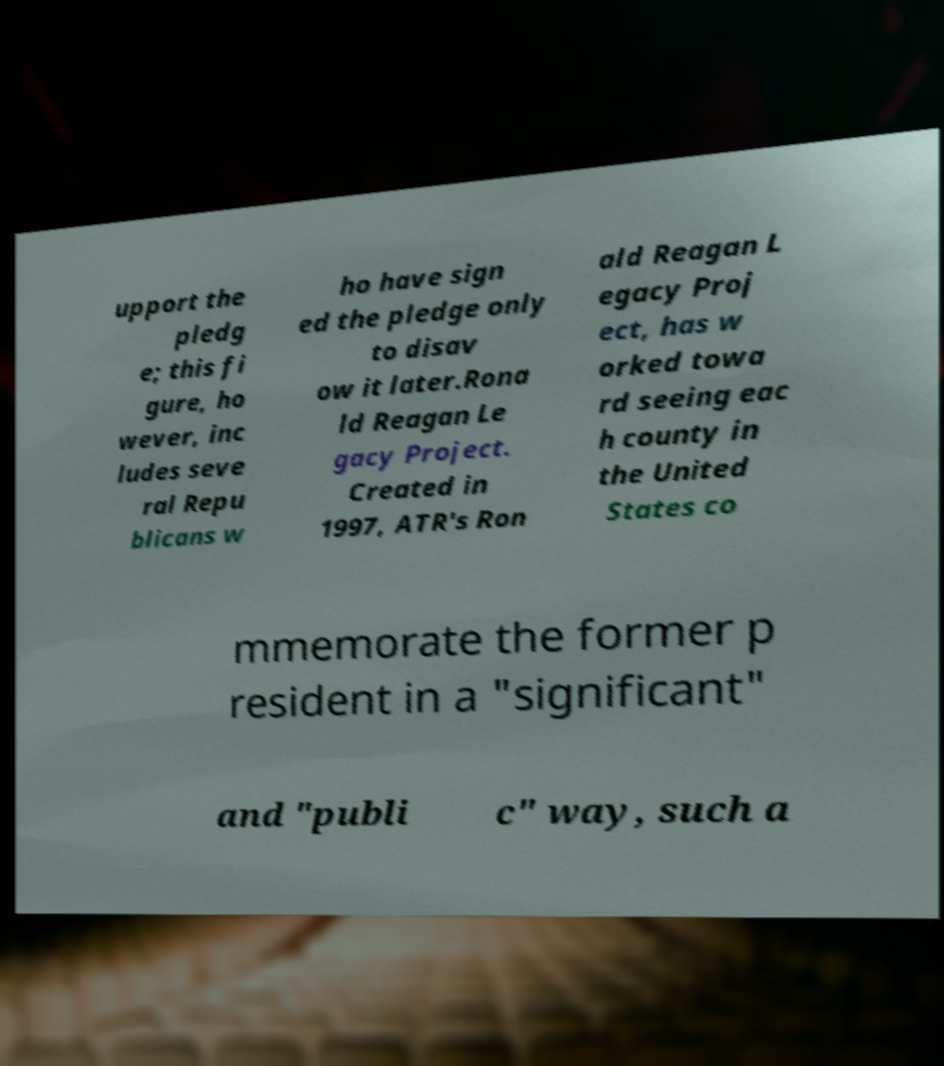For documentation purposes, I need the text within this image transcribed. Could you provide that? upport the pledg e; this fi gure, ho wever, inc ludes seve ral Repu blicans w ho have sign ed the pledge only to disav ow it later.Rona ld Reagan Le gacy Project. Created in 1997, ATR's Ron ald Reagan L egacy Proj ect, has w orked towa rd seeing eac h county in the United States co mmemorate the former p resident in a "significant" and "publi c" way, such a 